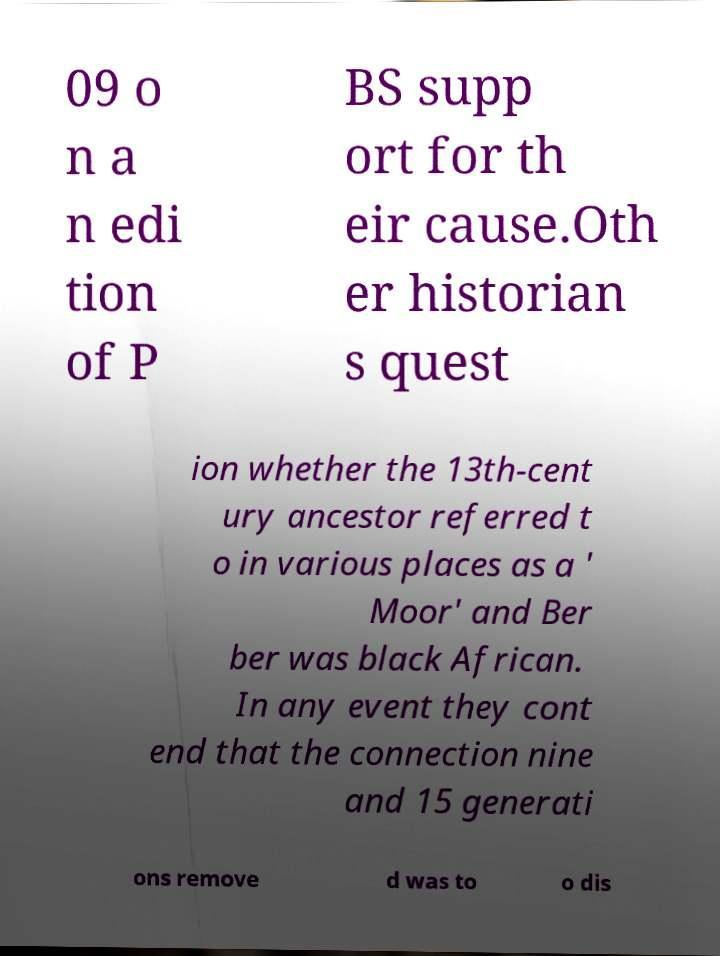Could you extract and type out the text from this image? 09 o n a n edi tion of P BS supp ort for th eir cause.Oth er historian s quest ion whether the 13th-cent ury ancestor referred t o in various places as a ' Moor' and Ber ber was black African. In any event they cont end that the connection nine and 15 generati ons remove d was to o dis 